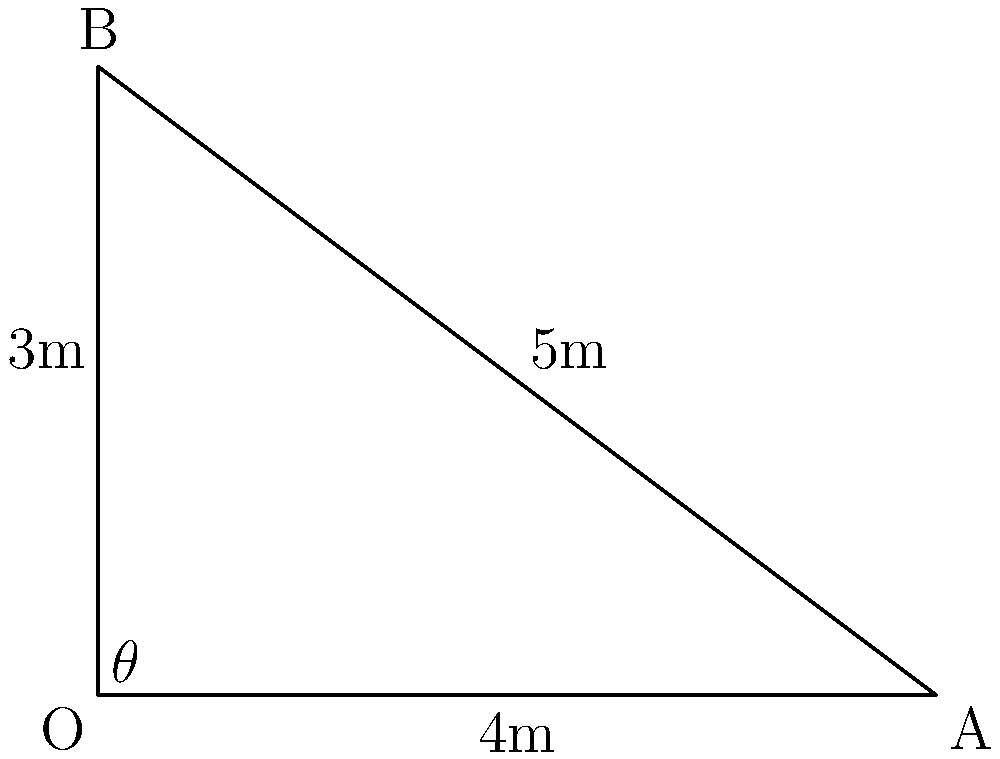In your vinyl listening room, you want to create an equilateral triangle between your two speakers and the sweet spot where you'll be sitting. If the distance between the speakers is 4 meters, and the height of the triangle (distance from the midpoint of the speaker line to your listening position) is 3 meters, what is the angle $\theta$ (in degrees) between the speaker line and the line from one speaker to your listening position? Let's approach this step-by-step:

1) We have a right triangle with the following measurements:
   - Base (half the distance between speakers) = 4/2 = 2 meters
   - Height (distance to listening position) = 3 meters

2) We need to find the angle $\theta$ at the base of this right triangle.

3) We can use the tangent function to find this angle:

   $$\tan(\theta) = \frac{\text{opposite}}{\text{adjacent}} = \frac{3}{2}$$

4) To find $\theta$, we need to take the inverse tangent (arctangent):

   $$\theta = \arctan(\frac{3}{2})$$

5) Using a calculator or mathematical software:

   $$\theta \approx 56.31^\circ$$

6) However, this is not our final answer. Remember, we want the angle between the speaker line and the line to the listening position. This angle is the complement of the angle we just found.

7) To get our final answer, we subtract this angle from 90°:

   $$90^\circ - 56.31^\circ \approx 33.69^\circ$$

Therefore, the angle between the speaker line and the line from one speaker to your listening position is approximately 33.69°.
Answer: 33.69° 